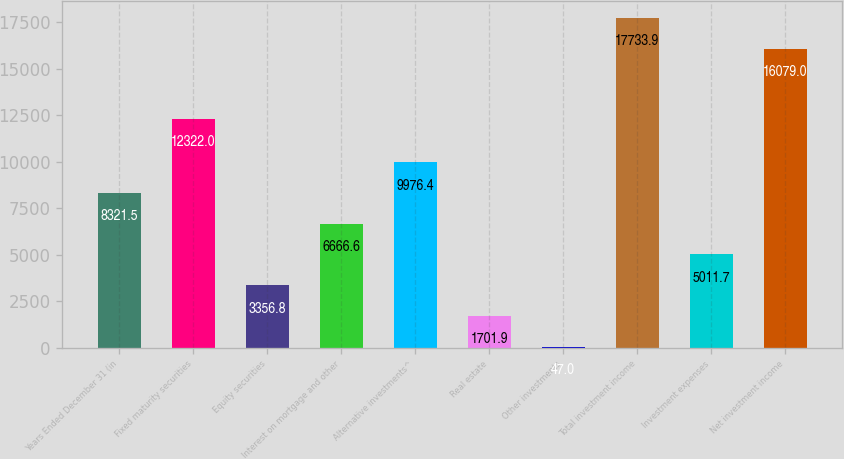Convert chart to OTSL. <chart><loc_0><loc_0><loc_500><loc_500><bar_chart><fcel>Years Ended December 31 (in<fcel>Fixed maturity securities<fcel>Equity securities<fcel>Interest on mortgage and other<fcel>Alternative investments^<fcel>Real estate<fcel>Other investments<fcel>Total investment income<fcel>Investment expenses<fcel>Net investment income<nl><fcel>8321.5<fcel>12322<fcel>3356.8<fcel>6666.6<fcel>9976.4<fcel>1701.9<fcel>47<fcel>17733.9<fcel>5011.7<fcel>16079<nl></chart> 